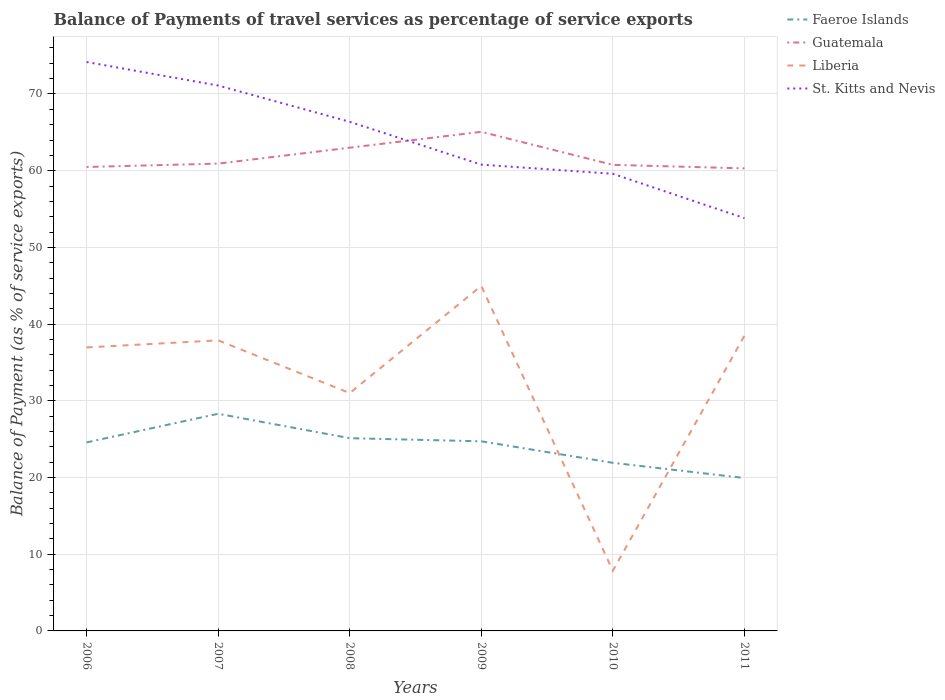Is the number of lines equal to the number of legend labels?
Provide a succinct answer. Yes. Across all years, what is the maximum balance of payments of travel services in Liberia?
Provide a short and direct response. 7.84. What is the total balance of payments of travel services in Faeroe Islands in the graph?
Offer a terse response. 2.66. What is the difference between the highest and the second highest balance of payments of travel services in Liberia?
Give a very brief answer. 37.13. Are the values on the major ticks of Y-axis written in scientific E-notation?
Provide a succinct answer. No. Does the graph contain any zero values?
Provide a succinct answer. No. How many legend labels are there?
Provide a short and direct response. 4. What is the title of the graph?
Offer a terse response. Balance of Payments of travel services as percentage of service exports. Does "Bangladesh" appear as one of the legend labels in the graph?
Make the answer very short. No. What is the label or title of the X-axis?
Keep it short and to the point. Years. What is the label or title of the Y-axis?
Your answer should be very brief. Balance of Payment (as % of service exports). What is the Balance of Payment (as % of service exports) of Faeroe Islands in 2006?
Provide a succinct answer. 24.58. What is the Balance of Payment (as % of service exports) in Guatemala in 2006?
Give a very brief answer. 60.48. What is the Balance of Payment (as % of service exports) in Liberia in 2006?
Your answer should be very brief. 36.96. What is the Balance of Payment (as % of service exports) in St. Kitts and Nevis in 2006?
Ensure brevity in your answer.  74.17. What is the Balance of Payment (as % of service exports) of Faeroe Islands in 2007?
Provide a short and direct response. 28.31. What is the Balance of Payment (as % of service exports) of Guatemala in 2007?
Give a very brief answer. 60.92. What is the Balance of Payment (as % of service exports) in Liberia in 2007?
Make the answer very short. 37.88. What is the Balance of Payment (as % of service exports) in St. Kitts and Nevis in 2007?
Give a very brief answer. 71.11. What is the Balance of Payment (as % of service exports) in Faeroe Islands in 2008?
Your response must be concise. 25.13. What is the Balance of Payment (as % of service exports) of Guatemala in 2008?
Offer a terse response. 63. What is the Balance of Payment (as % of service exports) in Liberia in 2008?
Ensure brevity in your answer.  31.01. What is the Balance of Payment (as % of service exports) of St. Kitts and Nevis in 2008?
Offer a very short reply. 66.37. What is the Balance of Payment (as % of service exports) of Faeroe Islands in 2009?
Ensure brevity in your answer.  24.72. What is the Balance of Payment (as % of service exports) in Guatemala in 2009?
Keep it short and to the point. 65.07. What is the Balance of Payment (as % of service exports) in Liberia in 2009?
Provide a succinct answer. 44.98. What is the Balance of Payment (as % of service exports) in St. Kitts and Nevis in 2009?
Offer a very short reply. 60.79. What is the Balance of Payment (as % of service exports) of Faeroe Islands in 2010?
Your response must be concise. 21.92. What is the Balance of Payment (as % of service exports) of Guatemala in 2010?
Give a very brief answer. 60.76. What is the Balance of Payment (as % of service exports) in Liberia in 2010?
Your answer should be compact. 7.84. What is the Balance of Payment (as % of service exports) in St. Kitts and Nevis in 2010?
Your response must be concise. 59.6. What is the Balance of Payment (as % of service exports) of Faeroe Islands in 2011?
Offer a very short reply. 19.94. What is the Balance of Payment (as % of service exports) in Guatemala in 2011?
Keep it short and to the point. 60.31. What is the Balance of Payment (as % of service exports) in Liberia in 2011?
Offer a very short reply. 38.49. What is the Balance of Payment (as % of service exports) in St. Kitts and Nevis in 2011?
Your answer should be very brief. 53.82. Across all years, what is the maximum Balance of Payment (as % of service exports) in Faeroe Islands?
Provide a succinct answer. 28.31. Across all years, what is the maximum Balance of Payment (as % of service exports) of Guatemala?
Your answer should be compact. 65.07. Across all years, what is the maximum Balance of Payment (as % of service exports) in Liberia?
Your answer should be compact. 44.98. Across all years, what is the maximum Balance of Payment (as % of service exports) of St. Kitts and Nevis?
Provide a short and direct response. 74.17. Across all years, what is the minimum Balance of Payment (as % of service exports) in Faeroe Islands?
Ensure brevity in your answer.  19.94. Across all years, what is the minimum Balance of Payment (as % of service exports) in Guatemala?
Offer a very short reply. 60.31. Across all years, what is the minimum Balance of Payment (as % of service exports) of Liberia?
Give a very brief answer. 7.84. Across all years, what is the minimum Balance of Payment (as % of service exports) of St. Kitts and Nevis?
Give a very brief answer. 53.82. What is the total Balance of Payment (as % of service exports) in Faeroe Islands in the graph?
Provide a short and direct response. 144.59. What is the total Balance of Payment (as % of service exports) in Guatemala in the graph?
Provide a succinct answer. 370.54. What is the total Balance of Payment (as % of service exports) in Liberia in the graph?
Your response must be concise. 197.16. What is the total Balance of Payment (as % of service exports) in St. Kitts and Nevis in the graph?
Your answer should be compact. 385.85. What is the difference between the Balance of Payment (as % of service exports) of Faeroe Islands in 2006 and that in 2007?
Offer a terse response. -3.73. What is the difference between the Balance of Payment (as % of service exports) of Guatemala in 2006 and that in 2007?
Offer a very short reply. -0.44. What is the difference between the Balance of Payment (as % of service exports) in Liberia in 2006 and that in 2007?
Provide a succinct answer. -0.92. What is the difference between the Balance of Payment (as % of service exports) in St. Kitts and Nevis in 2006 and that in 2007?
Make the answer very short. 3.06. What is the difference between the Balance of Payment (as % of service exports) of Faeroe Islands in 2006 and that in 2008?
Make the answer very short. -0.55. What is the difference between the Balance of Payment (as % of service exports) in Guatemala in 2006 and that in 2008?
Make the answer very short. -2.52. What is the difference between the Balance of Payment (as % of service exports) in Liberia in 2006 and that in 2008?
Provide a short and direct response. 5.95. What is the difference between the Balance of Payment (as % of service exports) in St. Kitts and Nevis in 2006 and that in 2008?
Offer a very short reply. 7.8. What is the difference between the Balance of Payment (as % of service exports) of Faeroe Islands in 2006 and that in 2009?
Your response must be concise. -0.14. What is the difference between the Balance of Payment (as % of service exports) in Guatemala in 2006 and that in 2009?
Provide a short and direct response. -4.58. What is the difference between the Balance of Payment (as % of service exports) in Liberia in 2006 and that in 2009?
Offer a very short reply. -8.02. What is the difference between the Balance of Payment (as % of service exports) of St. Kitts and Nevis in 2006 and that in 2009?
Your response must be concise. 13.38. What is the difference between the Balance of Payment (as % of service exports) in Faeroe Islands in 2006 and that in 2010?
Give a very brief answer. 2.66. What is the difference between the Balance of Payment (as % of service exports) of Guatemala in 2006 and that in 2010?
Provide a succinct answer. -0.28. What is the difference between the Balance of Payment (as % of service exports) of Liberia in 2006 and that in 2010?
Provide a short and direct response. 29.11. What is the difference between the Balance of Payment (as % of service exports) of St. Kitts and Nevis in 2006 and that in 2010?
Offer a terse response. 14.57. What is the difference between the Balance of Payment (as % of service exports) of Faeroe Islands in 2006 and that in 2011?
Make the answer very short. 4.64. What is the difference between the Balance of Payment (as % of service exports) in Guatemala in 2006 and that in 2011?
Keep it short and to the point. 0.18. What is the difference between the Balance of Payment (as % of service exports) in Liberia in 2006 and that in 2011?
Your answer should be very brief. -1.53. What is the difference between the Balance of Payment (as % of service exports) in St. Kitts and Nevis in 2006 and that in 2011?
Ensure brevity in your answer.  20.35. What is the difference between the Balance of Payment (as % of service exports) in Faeroe Islands in 2007 and that in 2008?
Offer a very short reply. 3.18. What is the difference between the Balance of Payment (as % of service exports) in Guatemala in 2007 and that in 2008?
Your answer should be compact. -2.08. What is the difference between the Balance of Payment (as % of service exports) of Liberia in 2007 and that in 2008?
Provide a short and direct response. 6.87. What is the difference between the Balance of Payment (as % of service exports) in St. Kitts and Nevis in 2007 and that in 2008?
Offer a terse response. 4.73. What is the difference between the Balance of Payment (as % of service exports) in Faeroe Islands in 2007 and that in 2009?
Your answer should be compact. 3.59. What is the difference between the Balance of Payment (as % of service exports) in Guatemala in 2007 and that in 2009?
Keep it short and to the point. -4.14. What is the difference between the Balance of Payment (as % of service exports) in Liberia in 2007 and that in 2009?
Offer a terse response. -7.1. What is the difference between the Balance of Payment (as % of service exports) of St. Kitts and Nevis in 2007 and that in 2009?
Ensure brevity in your answer.  10.32. What is the difference between the Balance of Payment (as % of service exports) in Faeroe Islands in 2007 and that in 2010?
Keep it short and to the point. 6.39. What is the difference between the Balance of Payment (as % of service exports) in Guatemala in 2007 and that in 2010?
Provide a short and direct response. 0.16. What is the difference between the Balance of Payment (as % of service exports) in Liberia in 2007 and that in 2010?
Give a very brief answer. 30.04. What is the difference between the Balance of Payment (as % of service exports) in St. Kitts and Nevis in 2007 and that in 2010?
Give a very brief answer. 11.51. What is the difference between the Balance of Payment (as % of service exports) in Faeroe Islands in 2007 and that in 2011?
Provide a succinct answer. 8.37. What is the difference between the Balance of Payment (as % of service exports) in Guatemala in 2007 and that in 2011?
Your answer should be very brief. 0.62. What is the difference between the Balance of Payment (as % of service exports) in Liberia in 2007 and that in 2011?
Make the answer very short. -0.6. What is the difference between the Balance of Payment (as % of service exports) in St. Kitts and Nevis in 2007 and that in 2011?
Make the answer very short. 17.29. What is the difference between the Balance of Payment (as % of service exports) in Faeroe Islands in 2008 and that in 2009?
Your answer should be compact. 0.41. What is the difference between the Balance of Payment (as % of service exports) in Guatemala in 2008 and that in 2009?
Provide a short and direct response. -2.07. What is the difference between the Balance of Payment (as % of service exports) in Liberia in 2008 and that in 2009?
Make the answer very short. -13.97. What is the difference between the Balance of Payment (as % of service exports) in St. Kitts and Nevis in 2008 and that in 2009?
Give a very brief answer. 5.59. What is the difference between the Balance of Payment (as % of service exports) in Faeroe Islands in 2008 and that in 2010?
Provide a succinct answer. 3.21. What is the difference between the Balance of Payment (as % of service exports) in Guatemala in 2008 and that in 2010?
Your answer should be very brief. 2.24. What is the difference between the Balance of Payment (as % of service exports) of Liberia in 2008 and that in 2010?
Make the answer very short. 23.16. What is the difference between the Balance of Payment (as % of service exports) in St. Kitts and Nevis in 2008 and that in 2010?
Offer a terse response. 6.78. What is the difference between the Balance of Payment (as % of service exports) of Faeroe Islands in 2008 and that in 2011?
Provide a short and direct response. 5.19. What is the difference between the Balance of Payment (as % of service exports) of Guatemala in 2008 and that in 2011?
Keep it short and to the point. 2.69. What is the difference between the Balance of Payment (as % of service exports) in Liberia in 2008 and that in 2011?
Provide a succinct answer. -7.48. What is the difference between the Balance of Payment (as % of service exports) in St. Kitts and Nevis in 2008 and that in 2011?
Ensure brevity in your answer.  12.56. What is the difference between the Balance of Payment (as % of service exports) in Faeroe Islands in 2009 and that in 2010?
Your response must be concise. 2.8. What is the difference between the Balance of Payment (as % of service exports) of Guatemala in 2009 and that in 2010?
Provide a succinct answer. 4.31. What is the difference between the Balance of Payment (as % of service exports) in Liberia in 2009 and that in 2010?
Your answer should be compact. 37.13. What is the difference between the Balance of Payment (as % of service exports) in St. Kitts and Nevis in 2009 and that in 2010?
Make the answer very short. 1.19. What is the difference between the Balance of Payment (as % of service exports) in Faeroe Islands in 2009 and that in 2011?
Ensure brevity in your answer.  4.78. What is the difference between the Balance of Payment (as % of service exports) of Guatemala in 2009 and that in 2011?
Offer a very short reply. 4.76. What is the difference between the Balance of Payment (as % of service exports) in Liberia in 2009 and that in 2011?
Your answer should be very brief. 6.49. What is the difference between the Balance of Payment (as % of service exports) in St. Kitts and Nevis in 2009 and that in 2011?
Your answer should be very brief. 6.97. What is the difference between the Balance of Payment (as % of service exports) of Faeroe Islands in 2010 and that in 2011?
Your answer should be compact. 1.98. What is the difference between the Balance of Payment (as % of service exports) in Guatemala in 2010 and that in 2011?
Provide a short and direct response. 0.46. What is the difference between the Balance of Payment (as % of service exports) in Liberia in 2010 and that in 2011?
Provide a short and direct response. -30.64. What is the difference between the Balance of Payment (as % of service exports) of St. Kitts and Nevis in 2010 and that in 2011?
Give a very brief answer. 5.78. What is the difference between the Balance of Payment (as % of service exports) in Faeroe Islands in 2006 and the Balance of Payment (as % of service exports) in Guatemala in 2007?
Provide a succinct answer. -36.35. What is the difference between the Balance of Payment (as % of service exports) in Faeroe Islands in 2006 and the Balance of Payment (as % of service exports) in Liberia in 2007?
Ensure brevity in your answer.  -13.3. What is the difference between the Balance of Payment (as % of service exports) of Faeroe Islands in 2006 and the Balance of Payment (as % of service exports) of St. Kitts and Nevis in 2007?
Offer a terse response. -46.53. What is the difference between the Balance of Payment (as % of service exports) in Guatemala in 2006 and the Balance of Payment (as % of service exports) in Liberia in 2007?
Your response must be concise. 22.6. What is the difference between the Balance of Payment (as % of service exports) of Guatemala in 2006 and the Balance of Payment (as % of service exports) of St. Kitts and Nevis in 2007?
Your answer should be very brief. -10.62. What is the difference between the Balance of Payment (as % of service exports) in Liberia in 2006 and the Balance of Payment (as % of service exports) in St. Kitts and Nevis in 2007?
Ensure brevity in your answer.  -34.15. What is the difference between the Balance of Payment (as % of service exports) in Faeroe Islands in 2006 and the Balance of Payment (as % of service exports) in Guatemala in 2008?
Provide a short and direct response. -38.42. What is the difference between the Balance of Payment (as % of service exports) in Faeroe Islands in 2006 and the Balance of Payment (as % of service exports) in Liberia in 2008?
Ensure brevity in your answer.  -6.43. What is the difference between the Balance of Payment (as % of service exports) of Faeroe Islands in 2006 and the Balance of Payment (as % of service exports) of St. Kitts and Nevis in 2008?
Keep it short and to the point. -41.8. What is the difference between the Balance of Payment (as % of service exports) in Guatemala in 2006 and the Balance of Payment (as % of service exports) in Liberia in 2008?
Keep it short and to the point. 29.48. What is the difference between the Balance of Payment (as % of service exports) in Guatemala in 2006 and the Balance of Payment (as % of service exports) in St. Kitts and Nevis in 2008?
Offer a terse response. -5.89. What is the difference between the Balance of Payment (as % of service exports) in Liberia in 2006 and the Balance of Payment (as % of service exports) in St. Kitts and Nevis in 2008?
Provide a succinct answer. -29.42. What is the difference between the Balance of Payment (as % of service exports) of Faeroe Islands in 2006 and the Balance of Payment (as % of service exports) of Guatemala in 2009?
Make the answer very short. -40.49. What is the difference between the Balance of Payment (as % of service exports) of Faeroe Islands in 2006 and the Balance of Payment (as % of service exports) of Liberia in 2009?
Offer a terse response. -20.4. What is the difference between the Balance of Payment (as % of service exports) of Faeroe Islands in 2006 and the Balance of Payment (as % of service exports) of St. Kitts and Nevis in 2009?
Offer a very short reply. -36.21. What is the difference between the Balance of Payment (as % of service exports) in Guatemala in 2006 and the Balance of Payment (as % of service exports) in Liberia in 2009?
Your answer should be compact. 15.51. What is the difference between the Balance of Payment (as % of service exports) of Guatemala in 2006 and the Balance of Payment (as % of service exports) of St. Kitts and Nevis in 2009?
Provide a succinct answer. -0.3. What is the difference between the Balance of Payment (as % of service exports) of Liberia in 2006 and the Balance of Payment (as % of service exports) of St. Kitts and Nevis in 2009?
Your response must be concise. -23.83. What is the difference between the Balance of Payment (as % of service exports) of Faeroe Islands in 2006 and the Balance of Payment (as % of service exports) of Guatemala in 2010?
Keep it short and to the point. -36.18. What is the difference between the Balance of Payment (as % of service exports) of Faeroe Islands in 2006 and the Balance of Payment (as % of service exports) of Liberia in 2010?
Make the answer very short. 16.73. What is the difference between the Balance of Payment (as % of service exports) of Faeroe Islands in 2006 and the Balance of Payment (as % of service exports) of St. Kitts and Nevis in 2010?
Provide a succinct answer. -35.02. What is the difference between the Balance of Payment (as % of service exports) of Guatemala in 2006 and the Balance of Payment (as % of service exports) of Liberia in 2010?
Your response must be concise. 52.64. What is the difference between the Balance of Payment (as % of service exports) in Guatemala in 2006 and the Balance of Payment (as % of service exports) in St. Kitts and Nevis in 2010?
Your answer should be very brief. 0.89. What is the difference between the Balance of Payment (as % of service exports) of Liberia in 2006 and the Balance of Payment (as % of service exports) of St. Kitts and Nevis in 2010?
Make the answer very short. -22.64. What is the difference between the Balance of Payment (as % of service exports) of Faeroe Islands in 2006 and the Balance of Payment (as % of service exports) of Guatemala in 2011?
Ensure brevity in your answer.  -35.73. What is the difference between the Balance of Payment (as % of service exports) of Faeroe Islands in 2006 and the Balance of Payment (as % of service exports) of Liberia in 2011?
Provide a short and direct response. -13.91. What is the difference between the Balance of Payment (as % of service exports) in Faeroe Islands in 2006 and the Balance of Payment (as % of service exports) in St. Kitts and Nevis in 2011?
Ensure brevity in your answer.  -29.24. What is the difference between the Balance of Payment (as % of service exports) of Guatemala in 2006 and the Balance of Payment (as % of service exports) of Liberia in 2011?
Offer a very short reply. 22. What is the difference between the Balance of Payment (as % of service exports) of Guatemala in 2006 and the Balance of Payment (as % of service exports) of St. Kitts and Nevis in 2011?
Provide a succinct answer. 6.67. What is the difference between the Balance of Payment (as % of service exports) of Liberia in 2006 and the Balance of Payment (as % of service exports) of St. Kitts and Nevis in 2011?
Offer a terse response. -16.86. What is the difference between the Balance of Payment (as % of service exports) of Faeroe Islands in 2007 and the Balance of Payment (as % of service exports) of Guatemala in 2008?
Offer a terse response. -34.69. What is the difference between the Balance of Payment (as % of service exports) of Faeroe Islands in 2007 and the Balance of Payment (as % of service exports) of Liberia in 2008?
Your answer should be compact. -2.7. What is the difference between the Balance of Payment (as % of service exports) in Faeroe Islands in 2007 and the Balance of Payment (as % of service exports) in St. Kitts and Nevis in 2008?
Ensure brevity in your answer.  -38.06. What is the difference between the Balance of Payment (as % of service exports) in Guatemala in 2007 and the Balance of Payment (as % of service exports) in Liberia in 2008?
Your answer should be very brief. 29.91. What is the difference between the Balance of Payment (as % of service exports) in Guatemala in 2007 and the Balance of Payment (as % of service exports) in St. Kitts and Nevis in 2008?
Offer a very short reply. -5.45. What is the difference between the Balance of Payment (as % of service exports) in Liberia in 2007 and the Balance of Payment (as % of service exports) in St. Kitts and Nevis in 2008?
Provide a succinct answer. -28.49. What is the difference between the Balance of Payment (as % of service exports) of Faeroe Islands in 2007 and the Balance of Payment (as % of service exports) of Guatemala in 2009?
Your response must be concise. -36.76. What is the difference between the Balance of Payment (as % of service exports) of Faeroe Islands in 2007 and the Balance of Payment (as % of service exports) of Liberia in 2009?
Offer a very short reply. -16.67. What is the difference between the Balance of Payment (as % of service exports) of Faeroe Islands in 2007 and the Balance of Payment (as % of service exports) of St. Kitts and Nevis in 2009?
Your response must be concise. -32.48. What is the difference between the Balance of Payment (as % of service exports) of Guatemala in 2007 and the Balance of Payment (as % of service exports) of Liberia in 2009?
Your answer should be very brief. 15.94. What is the difference between the Balance of Payment (as % of service exports) of Guatemala in 2007 and the Balance of Payment (as % of service exports) of St. Kitts and Nevis in 2009?
Keep it short and to the point. 0.13. What is the difference between the Balance of Payment (as % of service exports) in Liberia in 2007 and the Balance of Payment (as % of service exports) in St. Kitts and Nevis in 2009?
Offer a very short reply. -22.91. What is the difference between the Balance of Payment (as % of service exports) in Faeroe Islands in 2007 and the Balance of Payment (as % of service exports) in Guatemala in 2010?
Offer a very short reply. -32.45. What is the difference between the Balance of Payment (as % of service exports) of Faeroe Islands in 2007 and the Balance of Payment (as % of service exports) of Liberia in 2010?
Give a very brief answer. 20.47. What is the difference between the Balance of Payment (as % of service exports) in Faeroe Islands in 2007 and the Balance of Payment (as % of service exports) in St. Kitts and Nevis in 2010?
Offer a very short reply. -31.29. What is the difference between the Balance of Payment (as % of service exports) of Guatemala in 2007 and the Balance of Payment (as % of service exports) of Liberia in 2010?
Offer a very short reply. 53.08. What is the difference between the Balance of Payment (as % of service exports) in Guatemala in 2007 and the Balance of Payment (as % of service exports) in St. Kitts and Nevis in 2010?
Offer a terse response. 1.33. What is the difference between the Balance of Payment (as % of service exports) in Liberia in 2007 and the Balance of Payment (as % of service exports) in St. Kitts and Nevis in 2010?
Offer a very short reply. -21.72. What is the difference between the Balance of Payment (as % of service exports) in Faeroe Islands in 2007 and the Balance of Payment (as % of service exports) in Guatemala in 2011?
Offer a very short reply. -32. What is the difference between the Balance of Payment (as % of service exports) of Faeroe Islands in 2007 and the Balance of Payment (as % of service exports) of Liberia in 2011?
Your answer should be compact. -10.18. What is the difference between the Balance of Payment (as % of service exports) of Faeroe Islands in 2007 and the Balance of Payment (as % of service exports) of St. Kitts and Nevis in 2011?
Your response must be concise. -25.51. What is the difference between the Balance of Payment (as % of service exports) in Guatemala in 2007 and the Balance of Payment (as % of service exports) in Liberia in 2011?
Provide a short and direct response. 22.44. What is the difference between the Balance of Payment (as % of service exports) of Guatemala in 2007 and the Balance of Payment (as % of service exports) of St. Kitts and Nevis in 2011?
Your answer should be very brief. 7.1. What is the difference between the Balance of Payment (as % of service exports) of Liberia in 2007 and the Balance of Payment (as % of service exports) of St. Kitts and Nevis in 2011?
Make the answer very short. -15.94. What is the difference between the Balance of Payment (as % of service exports) of Faeroe Islands in 2008 and the Balance of Payment (as % of service exports) of Guatemala in 2009?
Make the answer very short. -39.94. What is the difference between the Balance of Payment (as % of service exports) in Faeroe Islands in 2008 and the Balance of Payment (as % of service exports) in Liberia in 2009?
Your answer should be compact. -19.85. What is the difference between the Balance of Payment (as % of service exports) of Faeroe Islands in 2008 and the Balance of Payment (as % of service exports) of St. Kitts and Nevis in 2009?
Make the answer very short. -35.66. What is the difference between the Balance of Payment (as % of service exports) of Guatemala in 2008 and the Balance of Payment (as % of service exports) of Liberia in 2009?
Offer a very short reply. 18.02. What is the difference between the Balance of Payment (as % of service exports) of Guatemala in 2008 and the Balance of Payment (as % of service exports) of St. Kitts and Nevis in 2009?
Ensure brevity in your answer.  2.21. What is the difference between the Balance of Payment (as % of service exports) of Liberia in 2008 and the Balance of Payment (as % of service exports) of St. Kitts and Nevis in 2009?
Your response must be concise. -29.78. What is the difference between the Balance of Payment (as % of service exports) in Faeroe Islands in 2008 and the Balance of Payment (as % of service exports) in Guatemala in 2010?
Provide a short and direct response. -35.63. What is the difference between the Balance of Payment (as % of service exports) in Faeroe Islands in 2008 and the Balance of Payment (as % of service exports) in Liberia in 2010?
Make the answer very short. 17.28. What is the difference between the Balance of Payment (as % of service exports) of Faeroe Islands in 2008 and the Balance of Payment (as % of service exports) of St. Kitts and Nevis in 2010?
Offer a terse response. -34.47. What is the difference between the Balance of Payment (as % of service exports) of Guatemala in 2008 and the Balance of Payment (as % of service exports) of Liberia in 2010?
Make the answer very short. 55.16. What is the difference between the Balance of Payment (as % of service exports) of Guatemala in 2008 and the Balance of Payment (as % of service exports) of St. Kitts and Nevis in 2010?
Offer a terse response. 3.4. What is the difference between the Balance of Payment (as % of service exports) of Liberia in 2008 and the Balance of Payment (as % of service exports) of St. Kitts and Nevis in 2010?
Your response must be concise. -28.59. What is the difference between the Balance of Payment (as % of service exports) of Faeroe Islands in 2008 and the Balance of Payment (as % of service exports) of Guatemala in 2011?
Keep it short and to the point. -35.18. What is the difference between the Balance of Payment (as % of service exports) of Faeroe Islands in 2008 and the Balance of Payment (as % of service exports) of Liberia in 2011?
Make the answer very short. -13.36. What is the difference between the Balance of Payment (as % of service exports) in Faeroe Islands in 2008 and the Balance of Payment (as % of service exports) in St. Kitts and Nevis in 2011?
Your response must be concise. -28.69. What is the difference between the Balance of Payment (as % of service exports) of Guatemala in 2008 and the Balance of Payment (as % of service exports) of Liberia in 2011?
Your answer should be compact. 24.51. What is the difference between the Balance of Payment (as % of service exports) in Guatemala in 2008 and the Balance of Payment (as % of service exports) in St. Kitts and Nevis in 2011?
Your response must be concise. 9.18. What is the difference between the Balance of Payment (as % of service exports) in Liberia in 2008 and the Balance of Payment (as % of service exports) in St. Kitts and Nevis in 2011?
Ensure brevity in your answer.  -22.81. What is the difference between the Balance of Payment (as % of service exports) in Faeroe Islands in 2009 and the Balance of Payment (as % of service exports) in Guatemala in 2010?
Offer a terse response. -36.04. What is the difference between the Balance of Payment (as % of service exports) of Faeroe Islands in 2009 and the Balance of Payment (as % of service exports) of Liberia in 2010?
Ensure brevity in your answer.  16.88. What is the difference between the Balance of Payment (as % of service exports) of Faeroe Islands in 2009 and the Balance of Payment (as % of service exports) of St. Kitts and Nevis in 2010?
Your answer should be very brief. -34.88. What is the difference between the Balance of Payment (as % of service exports) in Guatemala in 2009 and the Balance of Payment (as % of service exports) in Liberia in 2010?
Your answer should be very brief. 57.22. What is the difference between the Balance of Payment (as % of service exports) of Guatemala in 2009 and the Balance of Payment (as % of service exports) of St. Kitts and Nevis in 2010?
Ensure brevity in your answer.  5.47. What is the difference between the Balance of Payment (as % of service exports) in Liberia in 2009 and the Balance of Payment (as % of service exports) in St. Kitts and Nevis in 2010?
Your answer should be compact. -14.62. What is the difference between the Balance of Payment (as % of service exports) in Faeroe Islands in 2009 and the Balance of Payment (as % of service exports) in Guatemala in 2011?
Give a very brief answer. -35.59. What is the difference between the Balance of Payment (as % of service exports) of Faeroe Islands in 2009 and the Balance of Payment (as % of service exports) of Liberia in 2011?
Give a very brief answer. -13.77. What is the difference between the Balance of Payment (as % of service exports) of Faeroe Islands in 2009 and the Balance of Payment (as % of service exports) of St. Kitts and Nevis in 2011?
Ensure brevity in your answer.  -29.1. What is the difference between the Balance of Payment (as % of service exports) of Guatemala in 2009 and the Balance of Payment (as % of service exports) of Liberia in 2011?
Offer a terse response. 26.58. What is the difference between the Balance of Payment (as % of service exports) of Guatemala in 2009 and the Balance of Payment (as % of service exports) of St. Kitts and Nevis in 2011?
Provide a succinct answer. 11.25. What is the difference between the Balance of Payment (as % of service exports) in Liberia in 2009 and the Balance of Payment (as % of service exports) in St. Kitts and Nevis in 2011?
Your response must be concise. -8.84. What is the difference between the Balance of Payment (as % of service exports) in Faeroe Islands in 2010 and the Balance of Payment (as % of service exports) in Guatemala in 2011?
Offer a very short reply. -38.39. What is the difference between the Balance of Payment (as % of service exports) of Faeroe Islands in 2010 and the Balance of Payment (as % of service exports) of Liberia in 2011?
Provide a succinct answer. -16.57. What is the difference between the Balance of Payment (as % of service exports) of Faeroe Islands in 2010 and the Balance of Payment (as % of service exports) of St. Kitts and Nevis in 2011?
Make the answer very short. -31.9. What is the difference between the Balance of Payment (as % of service exports) in Guatemala in 2010 and the Balance of Payment (as % of service exports) in Liberia in 2011?
Your answer should be very brief. 22.28. What is the difference between the Balance of Payment (as % of service exports) of Guatemala in 2010 and the Balance of Payment (as % of service exports) of St. Kitts and Nevis in 2011?
Your response must be concise. 6.94. What is the difference between the Balance of Payment (as % of service exports) of Liberia in 2010 and the Balance of Payment (as % of service exports) of St. Kitts and Nevis in 2011?
Offer a terse response. -45.97. What is the average Balance of Payment (as % of service exports) in Faeroe Islands per year?
Your answer should be very brief. 24.1. What is the average Balance of Payment (as % of service exports) of Guatemala per year?
Your response must be concise. 61.76. What is the average Balance of Payment (as % of service exports) in Liberia per year?
Ensure brevity in your answer.  32.86. What is the average Balance of Payment (as % of service exports) in St. Kitts and Nevis per year?
Give a very brief answer. 64.31. In the year 2006, what is the difference between the Balance of Payment (as % of service exports) in Faeroe Islands and Balance of Payment (as % of service exports) in Guatemala?
Provide a succinct answer. -35.91. In the year 2006, what is the difference between the Balance of Payment (as % of service exports) of Faeroe Islands and Balance of Payment (as % of service exports) of Liberia?
Provide a short and direct response. -12.38. In the year 2006, what is the difference between the Balance of Payment (as % of service exports) of Faeroe Islands and Balance of Payment (as % of service exports) of St. Kitts and Nevis?
Ensure brevity in your answer.  -49.59. In the year 2006, what is the difference between the Balance of Payment (as % of service exports) in Guatemala and Balance of Payment (as % of service exports) in Liberia?
Offer a terse response. 23.53. In the year 2006, what is the difference between the Balance of Payment (as % of service exports) in Guatemala and Balance of Payment (as % of service exports) in St. Kitts and Nevis?
Offer a very short reply. -13.69. In the year 2006, what is the difference between the Balance of Payment (as % of service exports) of Liberia and Balance of Payment (as % of service exports) of St. Kitts and Nevis?
Your response must be concise. -37.21. In the year 2007, what is the difference between the Balance of Payment (as % of service exports) of Faeroe Islands and Balance of Payment (as % of service exports) of Guatemala?
Your response must be concise. -32.61. In the year 2007, what is the difference between the Balance of Payment (as % of service exports) in Faeroe Islands and Balance of Payment (as % of service exports) in Liberia?
Keep it short and to the point. -9.57. In the year 2007, what is the difference between the Balance of Payment (as % of service exports) of Faeroe Islands and Balance of Payment (as % of service exports) of St. Kitts and Nevis?
Make the answer very short. -42.8. In the year 2007, what is the difference between the Balance of Payment (as % of service exports) of Guatemala and Balance of Payment (as % of service exports) of Liberia?
Provide a succinct answer. 23.04. In the year 2007, what is the difference between the Balance of Payment (as % of service exports) in Guatemala and Balance of Payment (as % of service exports) in St. Kitts and Nevis?
Your answer should be compact. -10.18. In the year 2007, what is the difference between the Balance of Payment (as % of service exports) of Liberia and Balance of Payment (as % of service exports) of St. Kitts and Nevis?
Your response must be concise. -33.22. In the year 2008, what is the difference between the Balance of Payment (as % of service exports) of Faeroe Islands and Balance of Payment (as % of service exports) of Guatemala?
Your answer should be very brief. -37.87. In the year 2008, what is the difference between the Balance of Payment (as % of service exports) in Faeroe Islands and Balance of Payment (as % of service exports) in Liberia?
Your response must be concise. -5.88. In the year 2008, what is the difference between the Balance of Payment (as % of service exports) of Faeroe Islands and Balance of Payment (as % of service exports) of St. Kitts and Nevis?
Your answer should be compact. -41.25. In the year 2008, what is the difference between the Balance of Payment (as % of service exports) of Guatemala and Balance of Payment (as % of service exports) of Liberia?
Your answer should be very brief. 31.99. In the year 2008, what is the difference between the Balance of Payment (as % of service exports) of Guatemala and Balance of Payment (as % of service exports) of St. Kitts and Nevis?
Offer a terse response. -3.37. In the year 2008, what is the difference between the Balance of Payment (as % of service exports) in Liberia and Balance of Payment (as % of service exports) in St. Kitts and Nevis?
Your response must be concise. -35.37. In the year 2009, what is the difference between the Balance of Payment (as % of service exports) of Faeroe Islands and Balance of Payment (as % of service exports) of Guatemala?
Provide a short and direct response. -40.35. In the year 2009, what is the difference between the Balance of Payment (as % of service exports) of Faeroe Islands and Balance of Payment (as % of service exports) of Liberia?
Your answer should be very brief. -20.26. In the year 2009, what is the difference between the Balance of Payment (as % of service exports) of Faeroe Islands and Balance of Payment (as % of service exports) of St. Kitts and Nevis?
Offer a terse response. -36.07. In the year 2009, what is the difference between the Balance of Payment (as % of service exports) of Guatemala and Balance of Payment (as % of service exports) of Liberia?
Offer a terse response. 20.09. In the year 2009, what is the difference between the Balance of Payment (as % of service exports) in Guatemala and Balance of Payment (as % of service exports) in St. Kitts and Nevis?
Your answer should be compact. 4.28. In the year 2009, what is the difference between the Balance of Payment (as % of service exports) in Liberia and Balance of Payment (as % of service exports) in St. Kitts and Nevis?
Make the answer very short. -15.81. In the year 2010, what is the difference between the Balance of Payment (as % of service exports) of Faeroe Islands and Balance of Payment (as % of service exports) of Guatemala?
Keep it short and to the point. -38.85. In the year 2010, what is the difference between the Balance of Payment (as % of service exports) in Faeroe Islands and Balance of Payment (as % of service exports) in Liberia?
Give a very brief answer. 14.07. In the year 2010, what is the difference between the Balance of Payment (as % of service exports) of Faeroe Islands and Balance of Payment (as % of service exports) of St. Kitts and Nevis?
Your response must be concise. -37.68. In the year 2010, what is the difference between the Balance of Payment (as % of service exports) of Guatemala and Balance of Payment (as % of service exports) of Liberia?
Your answer should be compact. 52.92. In the year 2010, what is the difference between the Balance of Payment (as % of service exports) in Guatemala and Balance of Payment (as % of service exports) in St. Kitts and Nevis?
Your answer should be compact. 1.16. In the year 2010, what is the difference between the Balance of Payment (as % of service exports) of Liberia and Balance of Payment (as % of service exports) of St. Kitts and Nevis?
Your answer should be compact. -51.75. In the year 2011, what is the difference between the Balance of Payment (as % of service exports) in Faeroe Islands and Balance of Payment (as % of service exports) in Guatemala?
Offer a terse response. -40.37. In the year 2011, what is the difference between the Balance of Payment (as % of service exports) in Faeroe Islands and Balance of Payment (as % of service exports) in Liberia?
Offer a terse response. -18.55. In the year 2011, what is the difference between the Balance of Payment (as % of service exports) in Faeroe Islands and Balance of Payment (as % of service exports) in St. Kitts and Nevis?
Your answer should be very brief. -33.88. In the year 2011, what is the difference between the Balance of Payment (as % of service exports) of Guatemala and Balance of Payment (as % of service exports) of Liberia?
Your response must be concise. 21.82. In the year 2011, what is the difference between the Balance of Payment (as % of service exports) in Guatemala and Balance of Payment (as % of service exports) in St. Kitts and Nevis?
Offer a terse response. 6.49. In the year 2011, what is the difference between the Balance of Payment (as % of service exports) in Liberia and Balance of Payment (as % of service exports) in St. Kitts and Nevis?
Provide a short and direct response. -15.33. What is the ratio of the Balance of Payment (as % of service exports) in Faeroe Islands in 2006 to that in 2007?
Keep it short and to the point. 0.87. What is the ratio of the Balance of Payment (as % of service exports) of Guatemala in 2006 to that in 2007?
Your answer should be very brief. 0.99. What is the ratio of the Balance of Payment (as % of service exports) in Liberia in 2006 to that in 2007?
Give a very brief answer. 0.98. What is the ratio of the Balance of Payment (as % of service exports) of St. Kitts and Nevis in 2006 to that in 2007?
Offer a very short reply. 1.04. What is the ratio of the Balance of Payment (as % of service exports) of Faeroe Islands in 2006 to that in 2008?
Offer a terse response. 0.98. What is the ratio of the Balance of Payment (as % of service exports) of Guatemala in 2006 to that in 2008?
Provide a succinct answer. 0.96. What is the ratio of the Balance of Payment (as % of service exports) of Liberia in 2006 to that in 2008?
Offer a very short reply. 1.19. What is the ratio of the Balance of Payment (as % of service exports) of St. Kitts and Nevis in 2006 to that in 2008?
Ensure brevity in your answer.  1.12. What is the ratio of the Balance of Payment (as % of service exports) of Guatemala in 2006 to that in 2009?
Offer a terse response. 0.93. What is the ratio of the Balance of Payment (as % of service exports) of Liberia in 2006 to that in 2009?
Offer a terse response. 0.82. What is the ratio of the Balance of Payment (as % of service exports) of St. Kitts and Nevis in 2006 to that in 2009?
Your response must be concise. 1.22. What is the ratio of the Balance of Payment (as % of service exports) of Faeroe Islands in 2006 to that in 2010?
Provide a succinct answer. 1.12. What is the ratio of the Balance of Payment (as % of service exports) of Guatemala in 2006 to that in 2010?
Your answer should be compact. 1. What is the ratio of the Balance of Payment (as % of service exports) in Liberia in 2006 to that in 2010?
Keep it short and to the point. 4.71. What is the ratio of the Balance of Payment (as % of service exports) in St. Kitts and Nevis in 2006 to that in 2010?
Provide a short and direct response. 1.24. What is the ratio of the Balance of Payment (as % of service exports) of Faeroe Islands in 2006 to that in 2011?
Make the answer very short. 1.23. What is the ratio of the Balance of Payment (as % of service exports) in Liberia in 2006 to that in 2011?
Offer a terse response. 0.96. What is the ratio of the Balance of Payment (as % of service exports) of St. Kitts and Nevis in 2006 to that in 2011?
Ensure brevity in your answer.  1.38. What is the ratio of the Balance of Payment (as % of service exports) in Faeroe Islands in 2007 to that in 2008?
Your response must be concise. 1.13. What is the ratio of the Balance of Payment (as % of service exports) of Liberia in 2007 to that in 2008?
Provide a short and direct response. 1.22. What is the ratio of the Balance of Payment (as % of service exports) of St. Kitts and Nevis in 2007 to that in 2008?
Keep it short and to the point. 1.07. What is the ratio of the Balance of Payment (as % of service exports) in Faeroe Islands in 2007 to that in 2009?
Keep it short and to the point. 1.15. What is the ratio of the Balance of Payment (as % of service exports) in Guatemala in 2007 to that in 2009?
Your response must be concise. 0.94. What is the ratio of the Balance of Payment (as % of service exports) of Liberia in 2007 to that in 2009?
Offer a very short reply. 0.84. What is the ratio of the Balance of Payment (as % of service exports) of St. Kitts and Nevis in 2007 to that in 2009?
Your answer should be compact. 1.17. What is the ratio of the Balance of Payment (as % of service exports) of Faeroe Islands in 2007 to that in 2010?
Provide a short and direct response. 1.29. What is the ratio of the Balance of Payment (as % of service exports) of Guatemala in 2007 to that in 2010?
Offer a very short reply. 1. What is the ratio of the Balance of Payment (as % of service exports) of Liberia in 2007 to that in 2010?
Offer a very short reply. 4.83. What is the ratio of the Balance of Payment (as % of service exports) of St. Kitts and Nevis in 2007 to that in 2010?
Offer a terse response. 1.19. What is the ratio of the Balance of Payment (as % of service exports) of Faeroe Islands in 2007 to that in 2011?
Provide a short and direct response. 1.42. What is the ratio of the Balance of Payment (as % of service exports) of Guatemala in 2007 to that in 2011?
Give a very brief answer. 1.01. What is the ratio of the Balance of Payment (as % of service exports) in Liberia in 2007 to that in 2011?
Make the answer very short. 0.98. What is the ratio of the Balance of Payment (as % of service exports) in St. Kitts and Nevis in 2007 to that in 2011?
Make the answer very short. 1.32. What is the ratio of the Balance of Payment (as % of service exports) of Faeroe Islands in 2008 to that in 2009?
Provide a short and direct response. 1.02. What is the ratio of the Balance of Payment (as % of service exports) in Guatemala in 2008 to that in 2009?
Make the answer very short. 0.97. What is the ratio of the Balance of Payment (as % of service exports) in Liberia in 2008 to that in 2009?
Your answer should be compact. 0.69. What is the ratio of the Balance of Payment (as % of service exports) in St. Kitts and Nevis in 2008 to that in 2009?
Provide a short and direct response. 1.09. What is the ratio of the Balance of Payment (as % of service exports) in Faeroe Islands in 2008 to that in 2010?
Give a very brief answer. 1.15. What is the ratio of the Balance of Payment (as % of service exports) in Guatemala in 2008 to that in 2010?
Ensure brevity in your answer.  1.04. What is the ratio of the Balance of Payment (as % of service exports) in Liberia in 2008 to that in 2010?
Your response must be concise. 3.95. What is the ratio of the Balance of Payment (as % of service exports) in St. Kitts and Nevis in 2008 to that in 2010?
Ensure brevity in your answer.  1.11. What is the ratio of the Balance of Payment (as % of service exports) of Faeroe Islands in 2008 to that in 2011?
Your answer should be compact. 1.26. What is the ratio of the Balance of Payment (as % of service exports) in Guatemala in 2008 to that in 2011?
Your answer should be very brief. 1.04. What is the ratio of the Balance of Payment (as % of service exports) in Liberia in 2008 to that in 2011?
Offer a terse response. 0.81. What is the ratio of the Balance of Payment (as % of service exports) of St. Kitts and Nevis in 2008 to that in 2011?
Make the answer very short. 1.23. What is the ratio of the Balance of Payment (as % of service exports) in Faeroe Islands in 2009 to that in 2010?
Offer a very short reply. 1.13. What is the ratio of the Balance of Payment (as % of service exports) in Guatemala in 2009 to that in 2010?
Provide a succinct answer. 1.07. What is the ratio of the Balance of Payment (as % of service exports) in Liberia in 2009 to that in 2010?
Ensure brevity in your answer.  5.73. What is the ratio of the Balance of Payment (as % of service exports) of St. Kitts and Nevis in 2009 to that in 2010?
Offer a very short reply. 1.02. What is the ratio of the Balance of Payment (as % of service exports) in Faeroe Islands in 2009 to that in 2011?
Offer a very short reply. 1.24. What is the ratio of the Balance of Payment (as % of service exports) of Guatemala in 2009 to that in 2011?
Your answer should be compact. 1.08. What is the ratio of the Balance of Payment (as % of service exports) of Liberia in 2009 to that in 2011?
Provide a short and direct response. 1.17. What is the ratio of the Balance of Payment (as % of service exports) of St. Kitts and Nevis in 2009 to that in 2011?
Your answer should be very brief. 1.13. What is the ratio of the Balance of Payment (as % of service exports) of Faeroe Islands in 2010 to that in 2011?
Provide a succinct answer. 1.1. What is the ratio of the Balance of Payment (as % of service exports) of Guatemala in 2010 to that in 2011?
Provide a short and direct response. 1.01. What is the ratio of the Balance of Payment (as % of service exports) of Liberia in 2010 to that in 2011?
Make the answer very short. 0.2. What is the ratio of the Balance of Payment (as % of service exports) of St. Kitts and Nevis in 2010 to that in 2011?
Offer a terse response. 1.11. What is the difference between the highest and the second highest Balance of Payment (as % of service exports) in Faeroe Islands?
Ensure brevity in your answer.  3.18. What is the difference between the highest and the second highest Balance of Payment (as % of service exports) of Guatemala?
Keep it short and to the point. 2.07. What is the difference between the highest and the second highest Balance of Payment (as % of service exports) of Liberia?
Your answer should be very brief. 6.49. What is the difference between the highest and the second highest Balance of Payment (as % of service exports) of St. Kitts and Nevis?
Provide a short and direct response. 3.06. What is the difference between the highest and the lowest Balance of Payment (as % of service exports) of Faeroe Islands?
Make the answer very short. 8.37. What is the difference between the highest and the lowest Balance of Payment (as % of service exports) of Guatemala?
Give a very brief answer. 4.76. What is the difference between the highest and the lowest Balance of Payment (as % of service exports) of Liberia?
Your response must be concise. 37.13. What is the difference between the highest and the lowest Balance of Payment (as % of service exports) in St. Kitts and Nevis?
Your answer should be compact. 20.35. 